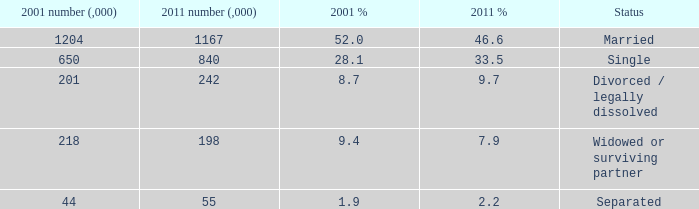How many 2011 % is 7.9? 1.0. 